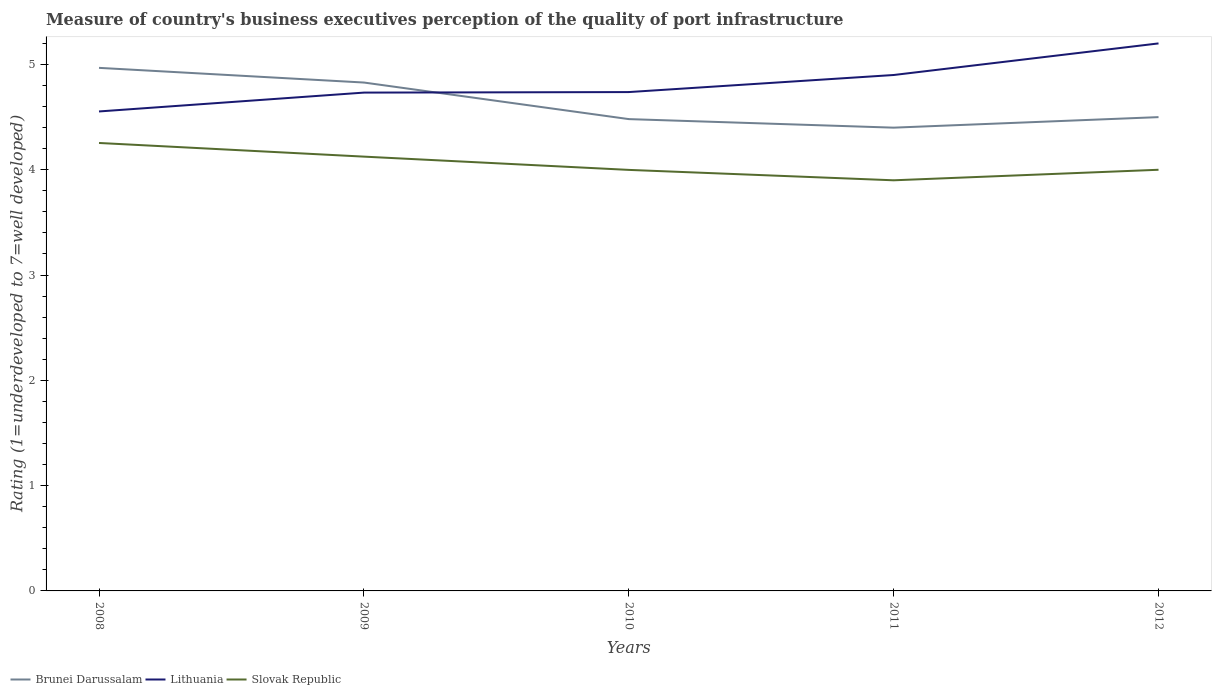Across all years, what is the maximum ratings of the quality of port infrastructure in Lithuania?
Offer a very short reply. 4.55. What is the total ratings of the quality of port infrastructure in Lithuania in the graph?
Your answer should be compact. -0.01. What is the difference between the highest and the second highest ratings of the quality of port infrastructure in Slovak Republic?
Your response must be concise. 0.35. What is the difference between the highest and the lowest ratings of the quality of port infrastructure in Lithuania?
Your answer should be compact. 2. What is the difference between two consecutive major ticks on the Y-axis?
Give a very brief answer. 1. Are the values on the major ticks of Y-axis written in scientific E-notation?
Make the answer very short. No. Does the graph contain grids?
Ensure brevity in your answer.  No. Where does the legend appear in the graph?
Keep it short and to the point. Bottom left. How many legend labels are there?
Provide a short and direct response. 3. How are the legend labels stacked?
Give a very brief answer. Horizontal. What is the title of the graph?
Offer a very short reply. Measure of country's business executives perception of the quality of port infrastructure. What is the label or title of the X-axis?
Ensure brevity in your answer.  Years. What is the label or title of the Y-axis?
Your response must be concise. Rating (1=underdeveloped to 7=well developed). What is the Rating (1=underdeveloped to 7=well developed) of Brunei Darussalam in 2008?
Your answer should be compact. 4.97. What is the Rating (1=underdeveloped to 7=well developed) of Lithuania in 2008?
Your answer should be compact. 4.55. What is the Rating (1=underdeveloped to 7=well developed) in Slovak Republic in 2008?
Provide a succinct answer. 4.25. What is the Rating (1=underdeveloped to 7=well developed) of Brunei Darussalam in 2009?
Your response must be concise. 4.83. What is the Rating (1=underdeveloped to 7=well developed) of Lithuania in 2009?
Offer a terse response. 4.73. What is the Rating (1=underdeveloped to 7=well developed) in Slovak Republic in 2009?
Offer a very short reply. 4.12. What is the Rating (1=underdeveloped to 7=well developed) in Brunei Darussalam in 2010?
Provide a short and direct response. 4.48. What is the Rating (1=underdeveloped to 7=well developed) in Lithuania in 2010?
Offer a very short reply. 4.74. What is the Rating (1=underdeveloped to 7=well developed) of Slovak Republic in 2010?
Keep it short and to the point. 4. What is the Rating (1=underdeveloped to 7=well developed) in Lithuania in 2011?
Make the answer very short. 4.9. What is the Rating (1=underdeveloped to 7=well developed) in Brunei Darussalam in 2012?
Offer a very short reply. 4.5. What is the Rating (1=underdeveloped to 7=well developed) of Lithuania in 2012?
Make the answer very short. 5.2. Across all years, what is the maximum Rating (1=underdeveloped to 7=well developed) of Brunei Darussalam?
Provide a succinct answer. 4.97. Across all years, what is the maximum Rating (1=underdeveloped to 7=well developed) in Lithuania?
Provide a short and direct response. 5.2. Across all years, what is the maximum Rating (1=underdeveloped to 7=well developed) in Slovak Republic?
Offer a terse response. 4.25. Across all years, what is the minimum Rating (1=underdeveloped to 7=well developed) of Lithuania?
Your response must be concise. 4.55. Across all years, what is the minimum Rating (1=underdeveloped to 7=well developed) in Slovak Republic?
Ensure brevity in your answer.  3.9. What is the total Rating (1=underdeveloped to 7=well developed) in Brunei Darussalam in the graph?
Offer a very short reply. 23.18. What is the total Rating (1=underdeveloped to 7=well developed) in Lithuania in the graph?
Your answer should be compact. 24.12. What is the total Rating (1=underdeveloped to 7=well developed) of Slovak Republic in the graph?
Offer a terse response. 20.28. What is the difference between the Rating (1=underdeveloped to 7=well developed) of Brunei Darussalam in 2008 and that in 2009?
Offer a very short reply. 0.14. What is the difference between the Rating (1=underdeveloped to 7=well developed) in Lithuania in 2008 and that in 2009?
Provide a succinct answer. -0.18. What is the difference between the Rating (1=underdeveloped to 7=well developed) in Slovak Republic in 2008 and that in 2009?
Your response must be concise. 0.13. What is the difference between the Rating (1=underdeveloped to 7=well developed) in Brunei Darussalam in 2008 and that in 2010?
Ensure brevity in your answer.  0.49. What is the difference between the Rating (1=underdeveloped to 7=well developed) in Lithuania in 2008 and that in 2010?
Provide a succinct answer. -0.18. What is the difference between the Rating (1=underdeveloped to 7=well developed) in Slovak Republic in 2008 and that in 2010?
Your response must be concise. 0.26. What is the difference between the Rating (1=underdeveloped to 7=well developed) of Brunei Darussalam in 2008 and that in 2011?
Your answer should be very brief. 0.57. What is the difference between the Rating (1=underdeveloped to 7=well developed) of Lithuania in 2008 and that in 2011?
Provide a succinct answer. -0.35. What is the difference between the Rating (1=underdeveloped to 7=well developed) in Slovak Republic in 2008 and that in 2011?
Offer a very short reply. 0.35. What is the difference between the Rating (1=underdeveloped to 7=well developed) in Brunei Darussalam in 2008 and that in 2012?
Your answer should be very brief. 0.47. What is the difference between the Rating (1=underdeveloped to 7=well developed) of Lithuania in 2008 and that in 2012?
Your answer should be very brief. -0.65. What is the difference between the Rating (1=underdeveloped to 7=well developed) in Slovak Republic in 2008 and that in 2012?
Provide a short and direct response. 0.25. What is the difference between the Rating (1=underdeveloped to 7=well developed) of Brunei Darussalam in 2009 and that in 2010?
Your answer should be compact. 0.35. What is the difference between the Rating (1=underdeveloped to 7=well developed) of Lithuania in 2009 and that in 2010?
Your answer should be very brief. -0.01. What is the difference between the Rating (1=underdeveloped to 7=well developed) of Slovak Republic in 2009 and that in 2010?
Your response must be concise. 0.13. What is the difference between the Rating (1=underdeveloped to 7=well developed) in Brunei Darussalam in 2009 and that in 2011?
Your answer should be very brief. 0.43. What is the difference between the Rating (1=underdeveloped to 7=well developed) of Lithuania in 2009 and that in 2011?
Give a very brief answer. -0.17. What is the difference between the Rating (1=underdeveloped to 7=well developed) in Slovak Republic in 2009 and that in 2011?
Keep it short and to the point. 0.22. What is the difference between the Rating (1=underdeveloped to 7=well developed) in Brunei Darussalam in 2009 and that in 2012?
Make the answer very short. 0.33. What is the difference between the Rating (1=underdeveloped to 7=well developed) of Lithuania in 2009 and that in 2012?
Provide a succinct answer. -0.47. What is the difference between the Rating (1=underdeveloped to 7=well developed) of Slovak Republic in 2009 and that in 2012?
Your answer should be compact. 0.12. What is the difference between the Rating (1=underdeveloped to 7=well developed) in Brunei Darussalam in 2010 and that in 2011?
Provide a short and direct response. 0.08. What is the difference between the Rating (1=underdeveloped to 7=well developed) in Lithuania in 2010 and that in 2011?
Offer a terse response. -0.16. What is the difference between the Rating (1=underdeveloped to 7=well developed) of Slovak Republic in 2010 and that in 2011?
Offer a terse response. 0.1. What is the difference between the Rating (1=underdeveloped to 7=well developed) of Brunei Darussalam in 2010 and that in 2012?
Keep it short and to the point. -0.02. What is the difference between the Rating (1=underdeveloped to 7=well developed) of Lithuania in 2010 and that in 2012?
Make the answer very short. -0.46. What is the difference between the Rating (1=underdeveloped to 7=well developed) in Slovak Republic in 2010 and that in 2012?
Your answer should be compact. -0. What is the difference between the Rating (1=underdeveloped to 7=well developed) of Brunei Darussalam in 2011 and that in 2012?
Keep it short and to the point. -0.1. What is the difference between the Rating (1=underdeveloped to 7=well developed) of Slovak Republic in 2011 and that in 2012?
Provide a short and direct response. -0.1. What is the difference between the Rating (1=underdeveloped to 7=well developed) of Brunei Darussalam in 2008 and the Rating (1=underdeveloped to 7=well developed) of Lithuania in 2009?
Your response must be concise. 0.23. What is the difference between the Rating (1=underdeveloped to 7=well developed) of Brunei Darussalam in 2008 and the Rating (1=underdeveloped to 7=well developed) of Slovak Republic in 2009?
Give a very brief answer. 0.84. What is the difference between the Rating (1=underdeveloped to 7=well developed) in Lithuania in 2008 and the Rating (1=underdeveloped to 7=well developed) in Slovak Republic in 2009?
Provide a short and direct response. 0.43. What is the difference between the Rating (1=underdeveloped to 7=well developed) of Brunei Darussalam in 2008 and the Rating (1=underdeveloped to 7=well developed) of Lithuania in 2010?
Give a very brief answer. 0.23. What is the difference between the Rating (1=underdeveloped to 7=well developed) in Brunei Darussalam in 2008 and the Rating (1=underdeveloped to 7=well developed) in Slovak Republic in 2010?
Keep it short and to the point. 0.97. What is the difference between the Rating (1=underdeveloped to 7=well developed) of Lithuania in 2008 and the Rating (1=underdeveloped to 7=well developed) of Slovak Republic in 2010?
Your answer should be compact. 0.56. What is the difference between the Rating (1=underdeveloped to 7=well developed) of Brunei Darussalam in 2008 and the Rating (1=underdeveloped to 7=well developed) of Lithuania in 2011?
Offer a very short reply. 0.07. What is the difference between the Rating (1=underdeveloped to 7=well developed) in Brunei Darussalam in 2008 and the Rating (1=underdeveloped to 7=well developed) in Slovak Republic in 2011?
Offer a very short reply. 1.07. What is the difference between the Rating (1=underdeveloped to 7=well developed) in Lithuania in 2008 and the Rating (1=underdeveloped to 7=well developed) in Slovak Republic in 2011?
Provide a short and direct response. 0.65. What is the difference between the Rating (1=underdeveloped to 7=well developed) in Brunei Darussalam in 2008 and the Rating (1=underdeveloped to 7=well developed) in Lithuania in 2012?
Offer a terse response. -0.23. What is the difference between the Rating (1=underdeveloped to 7=well developed) of Brunei Darussalam in 2008 and the Rating (1=underdeveloped to 7=well developed) of Slovak Republic in 2012?
Give a very brief answer. 0.97. What is the difference between the Rating (1=underdeveloped to 7=well developed) in Lithuania in 2008 and the Rating (1=underdeveloped to 7=well developed) in Slovak Republic in 2012?
Offer a terse response. 0.55. What is the difference between the Rating (1=underdeveloped to 7=well developed) in Brunei Darussalam in 2009 and the Rating (1=underdeveloped to 7=well developed) in Lithuania in 2010?
Keep it short and to the point. 0.09. What is the difference between the Rating (1=underdeveloped to 7=well developed) in Brunei Darussalam in 2009 and the Rating (1=underdeveloped to 7=well developed) in Slovak Republic in 2010?
Your answer should be very brief. 0.83. What is the difference between the Rating (1=underdeveloped to 7=well developed) of Lithuania in 2009 and the Rating (1=underdeveloped to 7=well developed) of Slovak Republic in 2010?
Ensure brevity in your answer.  0.73. What is the difference between the Rating (1=underdeveloped to 7=well developed) of Brunei Darussalam in 2009 and the Rating (1=underdeveloped to 7=well developed) of Lithuania in 2011?
Provide a succinct answer. -0.07. What is the difference between the Rating (1=underdeveloped to 7=well developed) in Lithuania in 2009 and the Rating (1=underdeveloped to 7=well developed) in Slovak Republic in 2011?
Make the answer very short. 0.83. What is the difference between the Rating (1=underdeveloped to 7=well developed) in Brunei Darussalam in 2009 and the Rating (1=underdeveloped to 7=well developed) in Lithuania in 2012?
Give a very brief answer. -0.37. What is the difference between the Rating (1=underdeveloped to 7=well developed) of Brunei Darussalam in 2009 and the Rating (1=underdeveloped to 7=well developed) of Slovak Republic in 2012?
Make the answer very short. 0.83. What is the difference between the Rating (1=underdeveloped to 7=well developed) in Lithuania in 2009 and the Rating (1=underdeveloped to 7=well developed) in Slovak Republic in 2012?
Give a very brief answer. 0.73. What is the difference between the Rating (1=underdeveloped to 7=well developed) of Brunei Darussalam in 2010 and the Rating (1=underdeveloped to 7=well developed) of Lithuania in 2011?
Offer a very short reply. -0.42. What is the difference between the Rating (1=underdeveloped to 7=well developed) in Brunei Darussalam in 2010 and the Rating (1=underdeveloped to 7=well developed) in Slovak Republic in 2011?
Offer a terse response. 0.58. What is the difference between the Rating (1=underdeveloped to 7=well developed) in Lithuania in 2010 and the Rating (1=underdeveloped to 7=well developed) in Slovak Republic in 2011?
Ensure brevity in your answer.  0.84. What is the difference between the Rating (1=underdeveloped to 7=well developed) of Brunei Darussalam in 2010 and the Rating (1=underdeveloped to 7=well developed) of Lithuania in 2012?
Your answer should be very brief. -0.72. What is the difference between the Rating (1=underdeveloped to 7=well developed) in Brunei Darussalam in 2010 and the Rating (1=underdeveloped to 7=well developed) in Slovak Republic in 2012?
Give a very brief answer. 0.48. What is the difference between the Rating (1=underdeveloped to 7=well developed) in Lithuania in 2010 and the Rating (1=underdeveloped to 7=well developed) in Slovak Republic in 2012?
Give a very brief answer. 0.74. What is the difference between the Rating (1=underdeveloped to 7=well developed) of Brunei Darussalam in 2011 and the Rating (1=underdeveloped to 7=well developed) of Lithuania in 2012?
Your response must be concise. -0.8. What is the difference between the Rating (1=underdeveloped to 7=well developed) of Brunei Darussalam in 2011 and the Rating (1=underdeveloped to 7=well developed) of Slovak Republic in 2012?
Keep it short and to the point. 0.4. What is the average Rating (1=underdeveloped to 7=well developed) in Brunei Darussalam per year?
Give a very brief answer. 4.64. What is the average Rating (1=underdeveloped to 7=well developed) of Lithuania per year?
Provide a succinct answer. 4.82. What is the average Rating (1=underdeveloped to 7=well developed) of Slovak Republic per year?
Keep it short and to the point. 4.06. In the year 2008, what is the difference between the Rating (1=underdeveloped to 7=well developed) of Brunei Darussalam and Rating (1=underdeveloped to 7=well developed) of Lithuania?
Your answer should be compact. 0.41. In the year 2008, what is the difference between the Rating (1=underdeveloped to 7=well developed) of Brunei Darussalam and Rating (1=underdeveloped to 7=well developed) of Slovak Republic?
Provide a succinct answer. 0.71. In the year 2008, what is the difference between the Rating (1=underdeveloped to 7=well developed) of Lithuania and Rating (1=underdeveloped to 7=well developed) of Slovak Republic?
Make the answer very short. 0.3. In the year 2009, what is the difference between the Rating (1=underdeveloped to 7=well developed) in Brunei Darussalam and Rating (1=underdeveloped to 7=well developed) in Lithuania?
Keep it short and to the point. 0.1. In the year 2009, what is the difference between the Rating (1=underdeveloped to 7=well developed) in Brunei Darussalam and Rating (1=underdeveloped to 7=well developed) in Slovak Republic?
Provide a succinct answer. 0.7. In the year 2009, what is the difference between the Rating (1=underdeveloped to 7=well developed) of Lithuania and Rating (1=underdeveloped to 7=well developed) of Slovak Republic?
Offer a very short reply. 0.61. In the year 2010, what is the difference between the Rating (1=underdeveloped to 7=well developed) in Brunei Darussalam and Rating (1=underdeveloped to 7=well developed) in Lithuania?
Offer a terse response. -0.26. In the year 2010, what is the difference between the Rating (1=underdeveloped to 7=well developed) in Brunei Darussalam and Rating (1=underdeveloped to 7=well developed) in Slovak Republic?
Your answer should be compact. 0.48. In the year 2010, what is the difference between the Rating (1=underdeveloped to 7=well developed) in Lithuania and Rating (1=underdeveloped to 7=well developed) in Slovak Republic?
Keep it short and to the point. 0.74. In the year 2011, what is the difference between the Rating (1=underdeveloped to 7=well developed) of Brunei Darussalam and Rating (1=underdeveloped to 7=well developed) of Lithuania?
Provide a succinct answer. -0.5. In the year 2012, what is the difference between the Rating (1=underdeveloped to 7=well developed) in Lithuania and Rating (1=underdeveloped to 7=well developed) in Slovak Republic?
Ensure brevity in your answer.  1.2. What is the ratio of the Rating (1=underdeveloped to 7=well developed) in Brunei Darussalam in 2008 to that in 2009?
Keep it short and to the point. 1.03. What is the ratio of the Rating (1=underdeveloped to 7=well developed) of Lithuania in 2008 to that in 2009?
Make the answer very short. 0.96. What is the ratio of the Rating (1=underdeveloped to 7=well developed) of Slovak Republic in 2008 to that in 2009?
Offer a very short reply. 1.03. What is the ratio of the Rating (1=underdeveloped to 7=well developed) of Brunei Darussalam in 2008 to that in 2010?
Your answer should be compact. 1.11. What is the ratio of the Rating (1=underdeveloped to 7=well developed) of Lithuania in 2008 to that in 2010?
Your answer should be compact. 0.96. What is the ratio of the Rating (1=underdeveloped to 7=well developed) in Slovak Republic in 2008 to that in 2010?
Your response must be concise. 1.06. What is the ratio of the Rating (1=underdeveloped to 7=well developed) of Brunei Darussalam in 2008 to that in 2011?
Offer a terse response. 1.13. What is the ratio of the Rating (1=underdeveloped to 7=well developed) in Lithuania in 2008 to that in 2011?
Keep it short and to the point. 0.93. What is the ratio of the Rating (1=underdeveloped to 7=well developed) of Brunei Darussalam in 2008 to that in 2012?
Provide a short and direct response. 1.1. What is the ratio of the Rating (1=underdeveloped to 7=well developed) of Lithuania in 2008 to that in 2012?
Your response must be concise. 0.88. What is the ratio of the Rating (1=underdeveloped to 7=well developed) of Slovak Republic in 2008 to that in 2012?
Your answer should be compact. 1.06. What is the ratio of the Rating (1=underdeveloped to 7=well developed) of Brunei Darussalam in 2009 to that in 2010?
Provide a short and direct response. 1.08. What is the ratio of the Rating (1=underdeveloped to 7=well developed) in Slovak Republic in 2009 to that in 2010?
Keep it short and to the point. 1.03. What is the ratio of the Rating (1=underdeveloped to 7=well developed) in Brunei Darussalam in 2009 to that in 2011?
Offer a very short reply. 1.1. What is the ratio of the Rating (1=underdeveloped to 7=well developed) of Lithuania in 2009 to that in 2011?
Offer a very short reply. 0.97. What is the ratio of the Rating (1=underdeveloped to 7=well developed) in Slovak Republic in 2009 to that in 2011?
Your response must be concise. 1.06. What is the ratio of the Rating (1=underdeveloped to 7=well developed) in Brunei Darussalam in 2009 to that in 2012?
Offer a very short reply. 1.07. What is the ratio of the Rating (1=underdeveloped to 7=well developed) in Lithuania in 2009 to that in 2012?
Offer a very short reply. 0.91. What is the ratio of the Rating (1=underdeveloped to 7=well developed) of Slovak Republic in 2009 to that in 2012?
Ensure brevity in your answer.  1.03. What is the ratio of the Rating (1=underdeveloped to 7=well developed) in Brunei Darussalam in 2010 to that in 2011?
Offer a very short reply. 1.02. What is the ratio of the Rating (1=underdeveloped to 7=well developed) in Lithuania in 2010 to that in 2011?
Offer a very short reply. 0.97. What is the ratio of the Rating (1=underdeveloped to 7=well developed) in Slovak Republic in 2010 to that in 2011?
Ensure brevity in your answer.  1.03. What is the ratio of the Rating (1=underdeveloped to 7=well developed) in Brunei Darussalam in 2010 to that in 2012?
Your response must be concise. 1. What is the ratio of the Rating (1=underdeveloped to 7=well developed) of Lithuania in 2010 to that in 2012?
Your response must be concise. 0.91. What is the ratio of the Rating (1=underdeveloped to 7=well developed) of Brunei Darussalam in 2011 to that in 2012?
Keep it short and to the point. 0.98. What is the ratio of the Rating (1=underdeveloped to 7=well developed) of Lithuania in 2011 to that in 2012?
Your response must be concise. 0.94. What is the difference between the highest and the second highest Rating (1=underdeveloped to 7=well developed) of Brunei Darussalam?
Ensure brevity in your answer.  0.14. What is the difference between the highest and the second highest Rating (1=underdeveloped to 7=well developed) in Lithuania?
Your answer should be compact. 0.3. What is the difference between the highest and the second highest Rating (1=underdeveloped to 7=well developed) of Slovak Republic?
Provide a succinct answer. 0.13. What is the difference between the highest and the lowest Rating (1=underdeveloped to 7=well developed) of Brunei Darussalam?
Make the answer very short. 0.57. What is the difference between the highest and the lowest Rating (1=underdeveloped to 7=well developed) in Lithuania?
Your answer should be compact. 0.65. What is the difference between the highest and the lowest Rating (1=underdeveloped to 7=well developed) in Slovak Republic?
Give a very brief answer. 0.35. 